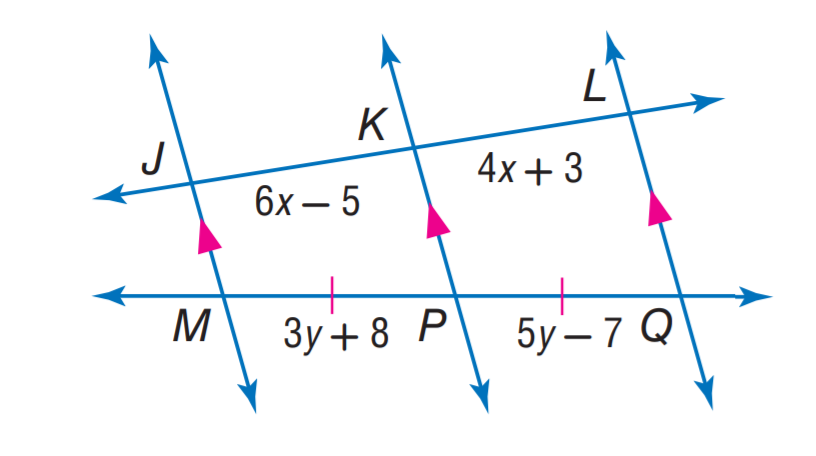Answer the mathemtical geometry problem and directly provide the correct option letter.
Question: Find y.
Choices: A: 6.5 B: 7 C: 7.5 D: 9 C 